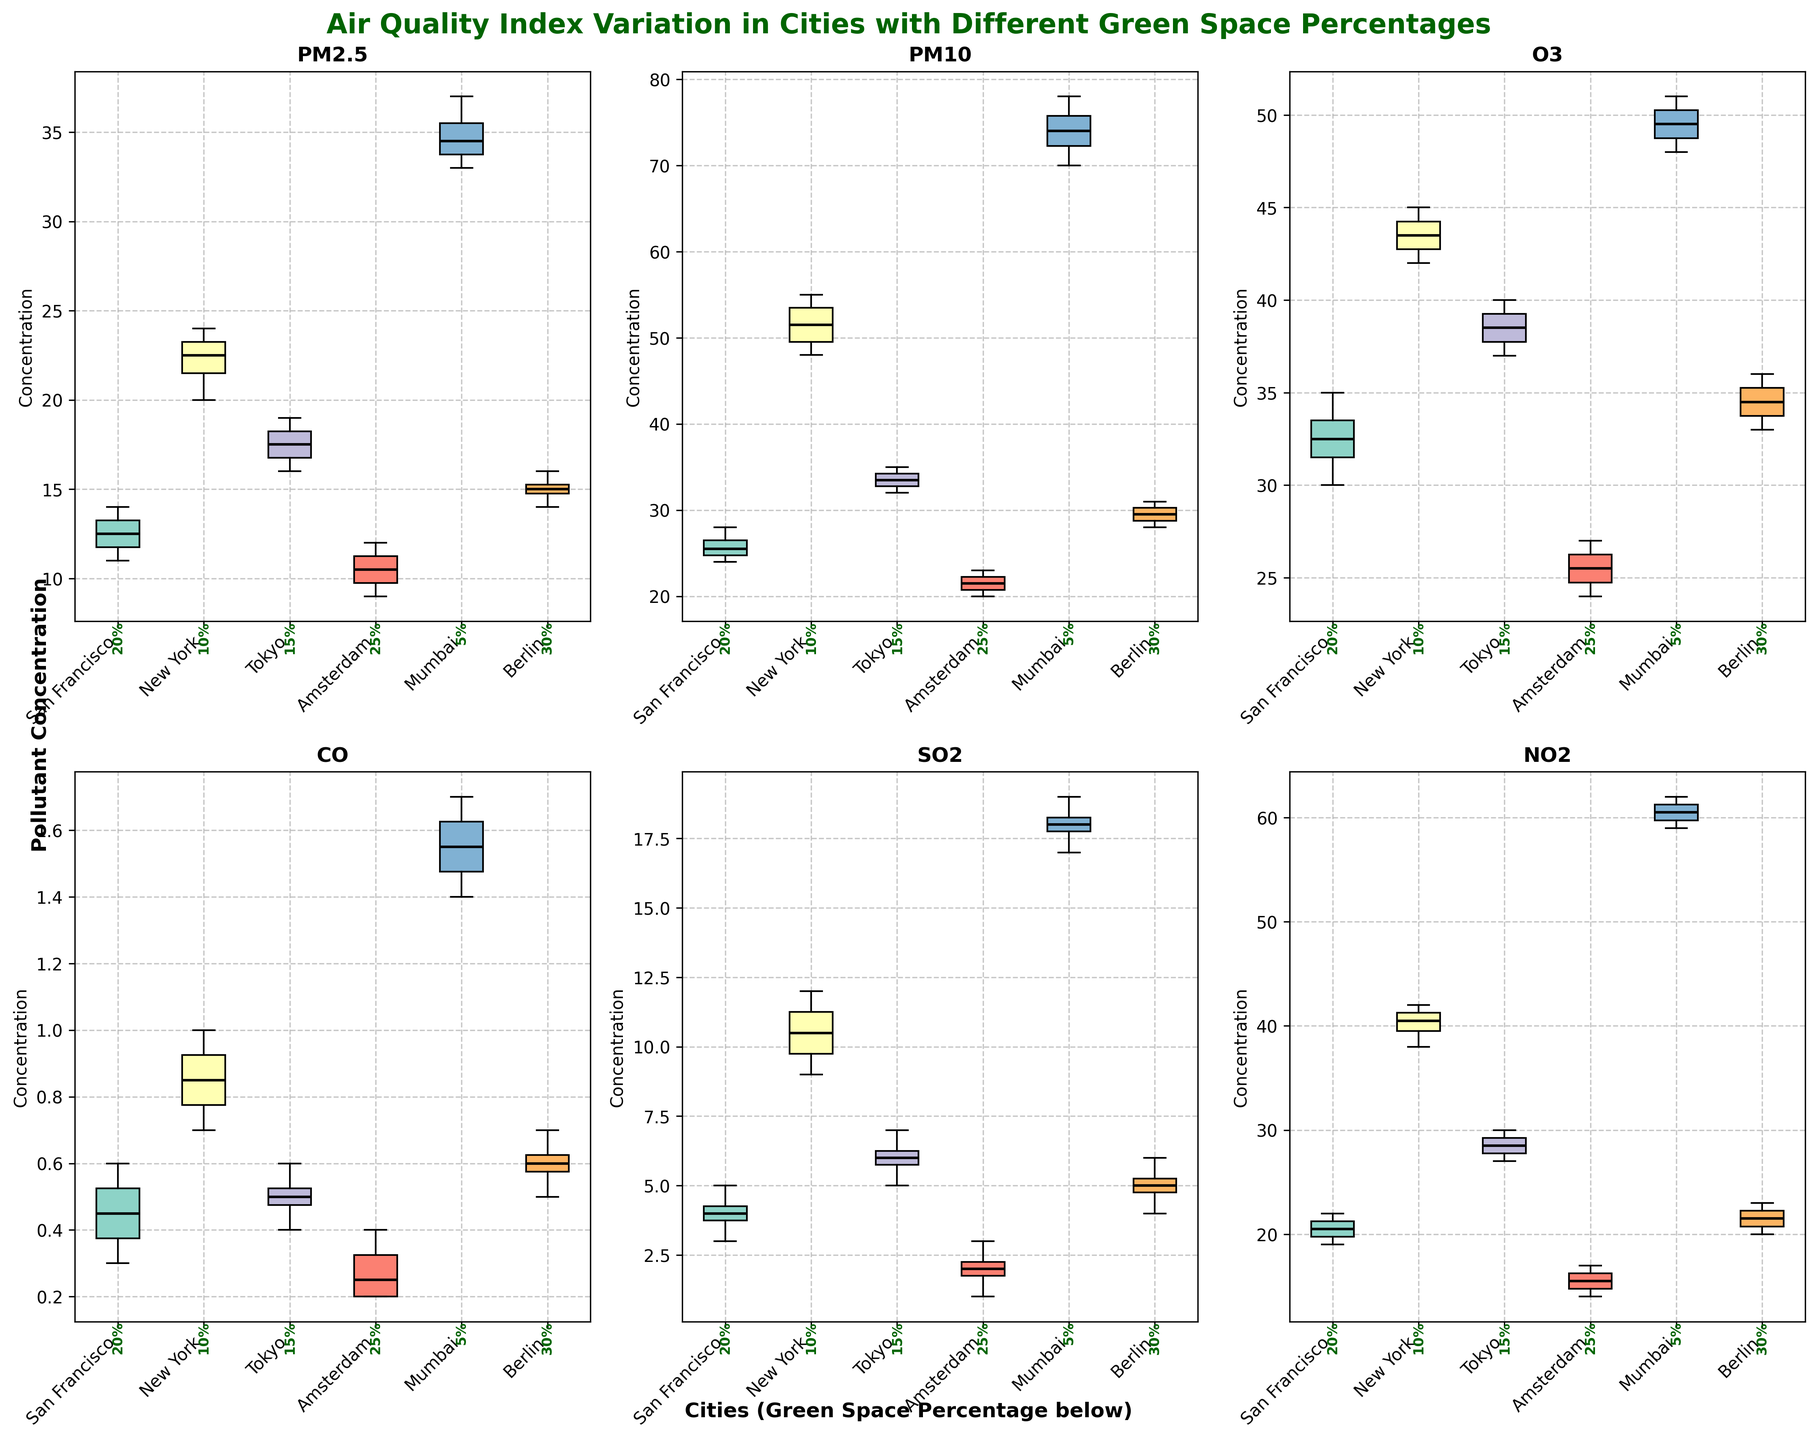How many different pollutants are analyzed in the figure? The title and each subplot axis label indicate that six different pollutants are analyzed: PM2.5, PM10, O3, CO, SO2, and NO2.
Answer: Six Which city appears to have the highest median value of PM2.5? The box plot for PM2.5 shows Mumbai having the highest median value compared to the other cities.
Answer: Mumbai What is the green space percentage for Berlin? The green space percentage for each city is indicated below the box plots on the x-axis. For Berlin, it's 30%.
Answer: 30% Which pollutant shows the most variation in New York? The extent of the box and whiskers in the New York box plots, which represent variation, is largest for PM10. This indicates higher variation in PM10 levels.
Answer: PM10 Comparing San Francisco and Tokyo, which city has a lower median value for CO? The median value for CO can be identified by looking at the central line in each box plot. Tokyo has a lower median value for CO compared to San Francisco.
Answer: Tokyo How does the median PM10 concentration in Amsterdam compare with that in Mumbai? By comparing the central lines in the box plots for PM10, it's clear that the median PM10 concentration in Amsterdam is significantly lower than in Mumbai.
Answer: Amsterdam is lower Are the PM2.5 levels in Berlin generally higher than those in Amsterdam? By comparing the box plots for PM2.5, Berlin's levels are slightly higher, with both medians and ranges being above those of Amsterdam.
Answer: Yes What's the range of SO2 concentrations in the data for Amsterdam? The range in a box plot is the distance between the box edges and the whiskers. For SO2 in Amsterdam, it ranges from 1 to 3.
Answer: 1 to 3 Based on the figure, which city has the most consistent O3 levels? The box plot for O3 shows the smallest box and whiskers for Amsterdam, indicating the most consistent levels.
Answer: Amsterdam Which city has the highest variability in NO2 concentrations? The box plot for NO2 shows the largest box and whiskers for Mumbai, indicating the highest variability in NO2 levels.
Answer: Mumbai 